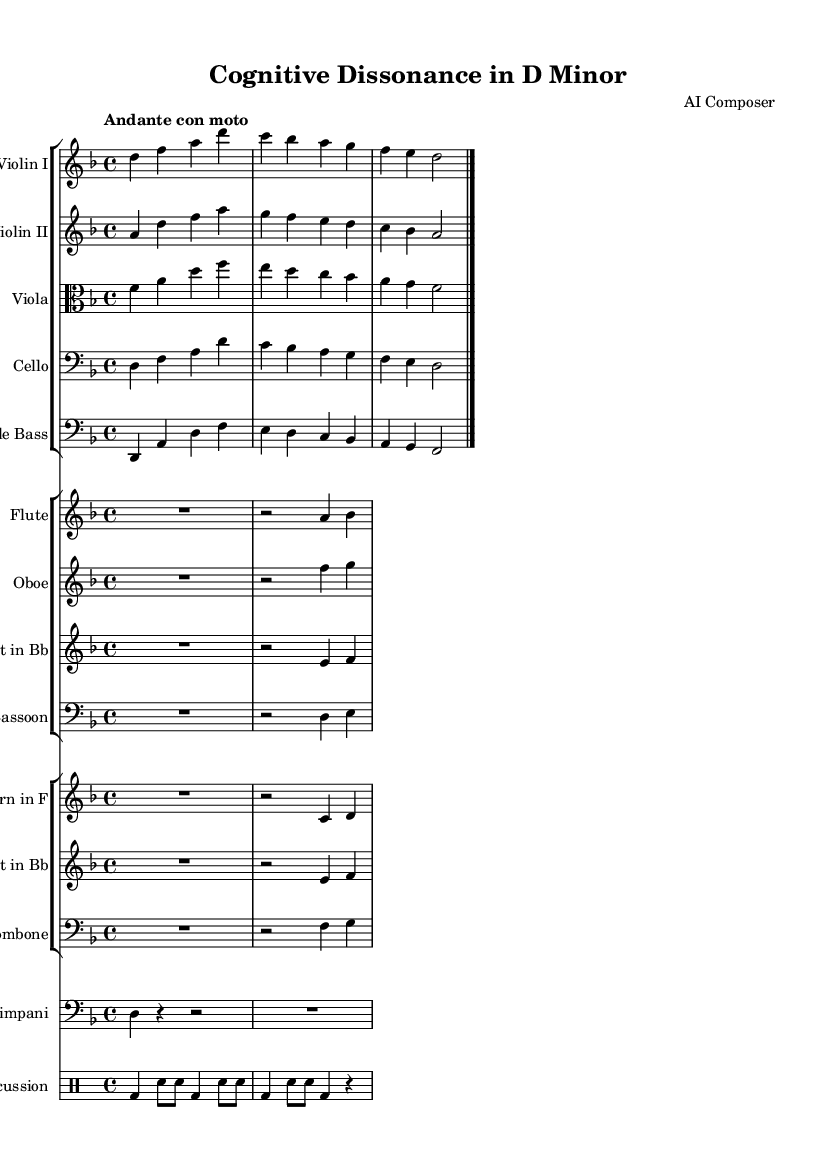What is the key signature of this symphony? The key signature is indicated by the clef and the placement of sharps and flats at the beginning of the staff. In this score, the key signature corresponds to D minor, which has one flat (B flat).
Answer: D minor What is the time signature of this piece? The time signature is represented at the beginning of the score. In this symphony, it is marked as 4/4, which means there are four beats in each measure and the quarter note gets one beat.
Answer: 4/4 What is the tempo marking for this symphony? The tempo marking is written above the staff as "Andante con moto." This indicates a moderately slow tempo with a slight movement.
Answer: Andante con moto How many different instrument groups are presented in the score? By examining the score layout, we can see the grouping of instruments. There are four groups of instruments: strings, woodwinds, brass, and percussion, making it a total of four groups.
Answer: Four Which instrument is playing the lowest pitch in this score? The lowest pitch in orchestral scores typically belongs to the double bass. By looking at the written notes in the cello and double bass staves, the double bass notes are lower than those of the cello.
Answer: Double Bass What is the rhythmic pattern of the timpani in the first measure? The rhythmic pattern can be observed in the timpani staff, where in the first measure it is notated as a quarter note followed by two rests and another quarter note. This gives us the rhythm of one note and two rests before another note.
Answer: Quarter, Rest, Rest, Quarter What is the function of the flute in this composition? The role of the flute can often be determined by its melodic line and placement within the harmonic structure. In many symphonic compositions, the flute often adds color and lightness, playing higher melodic passages that contrast with the strings.
Answer: Melody 